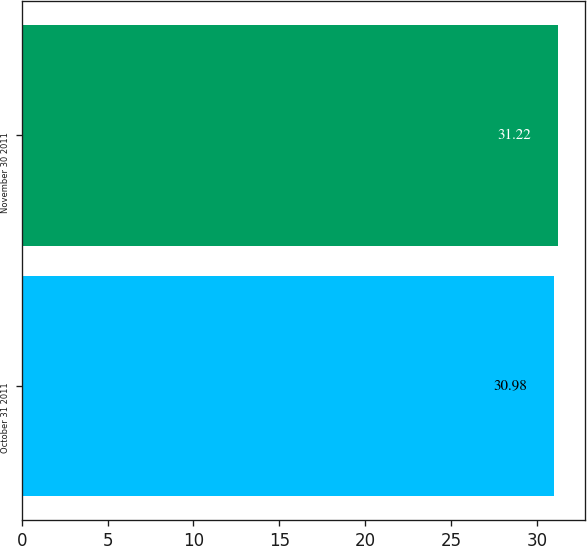<chart> <loc_0><loc_0><loc_500><loc_500><bar_chart><fcel>October 31 2011<fcel>November 30 2011<nl><fcel>30.98<fcel>31.22<nl></chart> 